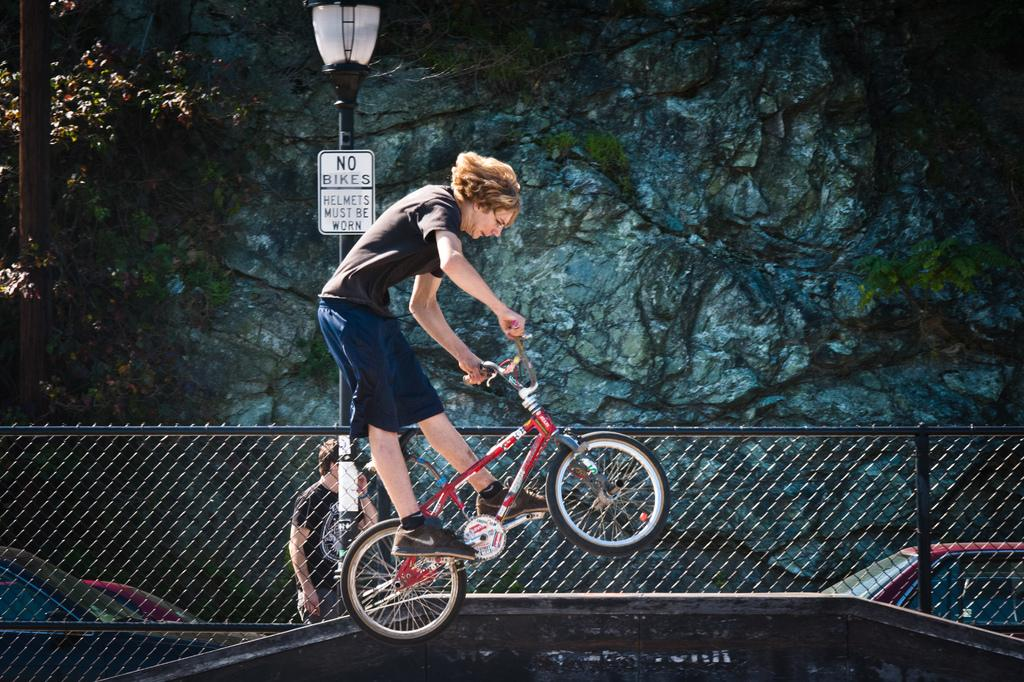Who is present in the image? There is a man in the image. What is the man doing in the image? The man is standing on a bicycle. What else can be seen in the image besides the man and the bicycle? There is a street lamp pole in the image. What type of music can be heard playing in the background of the image? There is no music present in the image, as it is a still photograph. 